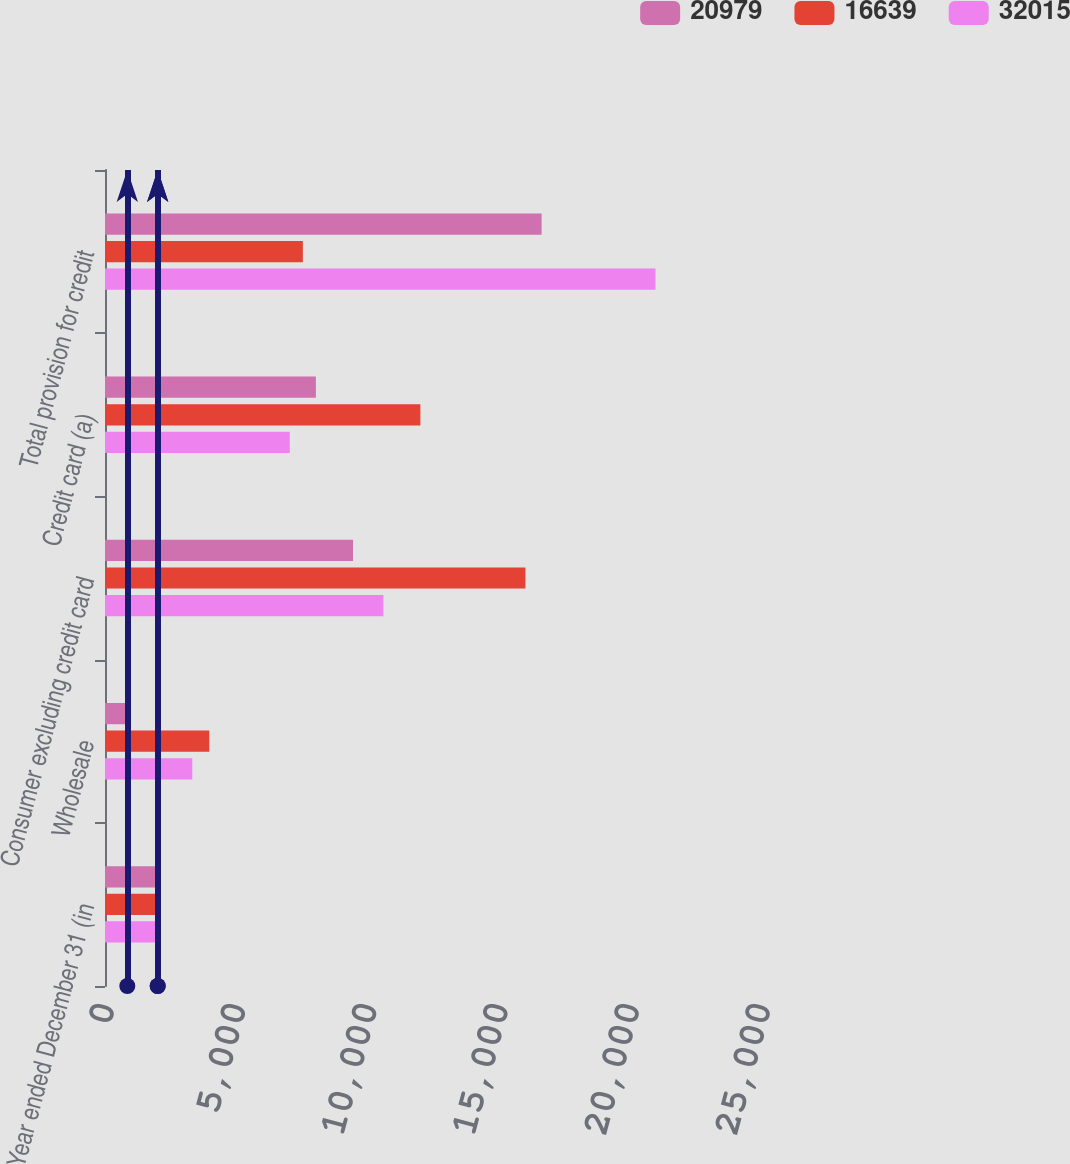Convert chart to OTSL. <chart><loc_0><loc_0><loc_500><loc_500><stacked_bar_chart><ecel><fcel>Year ended December 31 (in<fcel>Wholesale<fcel>Consumer excluding credit card<fcel>Credit card (a)<fcel>Total provision for credit<nl><fcel>20979<fcel>2010<fcel>850<fcel>9452<fcel>8037<fcel>16639<nl><fcel>16639<fcel>2009<fcel>3974<fcel>16022<fcel>12019<fcel>7539.5<nl><fcel>32015<fcel>2008<fcel>3327<fcel>10610<fcel>7042<fcel>20979<nl></chart> 